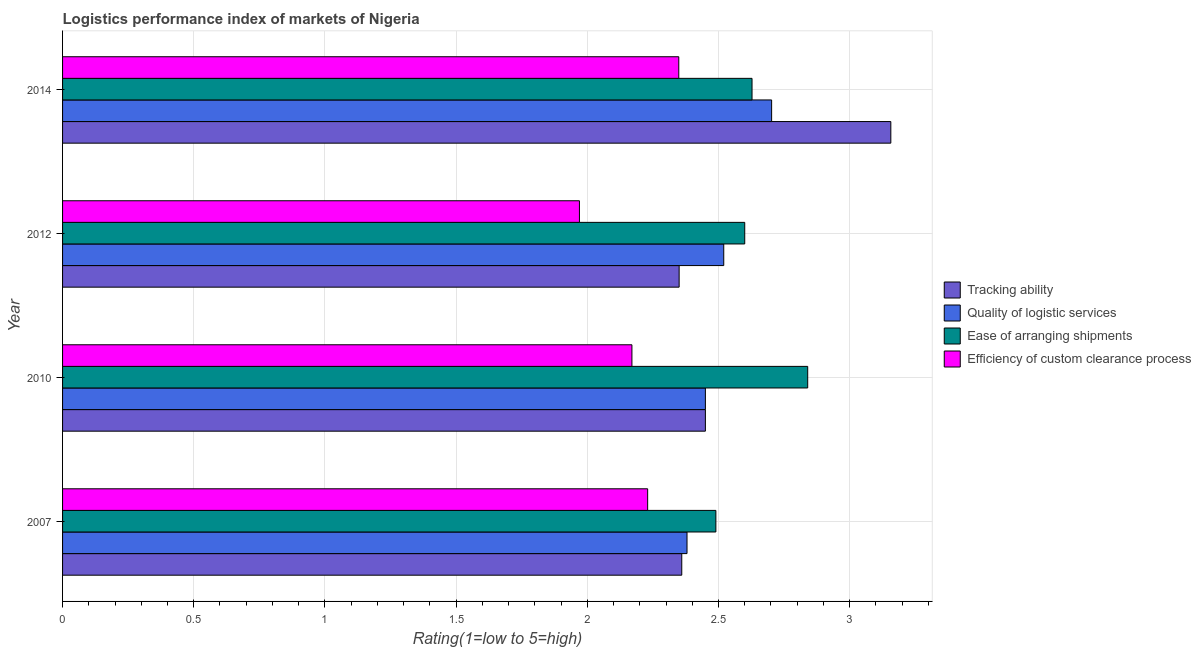How many different coloured bars are there?
Keep it short and to the point. 4. How many groups of bars are there?
Keep it short and to the point. 4. Are the number of bars per tick equal to the number of legend labels?
Your answer should be very brief. Yes. What is the label of the 3rd group of bars from the top?
Your response must be concise. 2010. In how many cases, is the number of bars for a given year not equal to the number of legend labels?
Make the answer very short. 0. What is the lpi rating of tracking ability in 2007?
Ensure brevity in your answer.  2.36. Across all years, what is the maximum lpi rating of efficiency of custom clearance process?
Offer a terse response. 2.35. Across all years, what is the minimum lpi rating of efficiency of custom clearance process?
Provide a short and direct response. 1.97. In which year was the lpi rating of quality of logistic services maximum?
Make the answer very short. 2014. In which year was the lpi rating of ease of arranging shipments minimum?
Your answer should be compact. 2007. What is the total lpi rating of quality of logistic services in the graph?
Make the answer very short. 10.05. What is the difference between the lpi rating of efficiency of custom clearance process in 2007 and that in 2014?
Keep it short and to the point. -0.12. What is the difference between the lpi rating of tracking ability in 2010 and the lpi rating of quality of logistic services in 2007?
Offer a very short reply. 0.07. What is the average lpi rating of ease of arranging shipments per year?
Your answer should be very brief. 2.64. In the year 2007, what is the difference between the lpi rating of efficiency of custom clearance process and lpi rating of ease of arranging shipments?
Offer a very short reply. -0.26. What is the ratio of the lpi rating of tracking ability in 2010 to that in 2014?
Offer a terse response. 0.78. Is the difference between the lpi rating of ease of arranging shipments in 2007 and 2012 greater than the difference between the lpi rating of quality of logistic services in 2007 and 2012?
Offer a very short reply. Yes. What is the difference between the highest and the second highest lpi rating of ease of arranging shipments?
Ensure brevity in your answer.  0.21. What is the difference between the highest and the lowest lpi rating of ease of arranging shipments?
Keep it short and to the point. 0.35. Is it the case that in every year, the sum of the lpi rating of quality of logistic services and lpi rating of efficiency of custom clearance process is greater than the sum of lpi rating of tracking ability and lpi rating of ease of arranging shipments?
Your answer should be compact. No. What does the 3rd bar from the top in 2012 represents?
Your answer should be very brief. Quality of logistic services. What does the 1st bar from the bottom in 2012 represents?
Make the answer very short. Tracking ability. Is it the case that in every year, the sum of the lpi rating of tracking ability and lpi rating of quality of logistic services is greater than the lpi rating of ease of arranging shipments?
Ensure brevity in your answer.  Yes. How many bars are there?
Make the answer very short. 16. How many years are there in the graph?
Your answer should be very brief. 4. Does the graph contain any zero values?
Your answer should be very brief. No. Does the graph contain grids?
Give a very brief answer. Yes. Where does the legend appear in the graph?
Your response must be concise. Center right. How are the legend labels stacked?
Keep it short and to the point. Vertical. What is the title of the graph?
Ensure brevity in your answer.  Logistics performance index of markets of Nigeria. Does "HFC gas" appear as one of the legend labels in the graph?
Give a very brief answer. No. What is the label or title of the X-axis?
Offer a terse response. Rating(1=low to 5=high). What is the label or title of the Y-axis?
Your answer should be very brief. Year. What is the Rating(1=low to 5=high) in Tracking ability in 2007?
Keep it short and to the point. 2.36. What is the Rating(1=low to 5=high) of Quality of logistic services in 2007?
Give a very brief answer. 2.38. What is the Rating(1=low to 5=high) of Ease of arranging shipments in 2007?
Provide a succinct answer. 2.49. What is the Rating(1=low to 5=high) in Efficiency of custom clearance process in 2007?
Provide a short and direct response. 2.23. What is the Rating(1=low to 5=high) in Tracking ability in 2010?
Offer a terse response. 2.45. What is the Rating(1=low to 5=high) in Quality of logistic services in 2010?
Provide a short and direct response. 2.45. What is the Rating(1=low to 5=high) of Ease of arranging shipments in 2010?
Your answer should be very brief. 2.84. What is the Rating(1=low to 5=high) of Efficiency of custom clearance process in 2010?
Give a very brief answer. 2.17. What is the Rating(1=low to 5=high) of Tracking ability in 2012?
Provide a succinct answer. 2.35. What is the Rating(1=low to 5=high) in Quality of logistic services in 2012?
Offer a very short reply. 2.52. What is the Rating(1=low to 5=high) of Efficiency of custom clearance process in 2012?
Make the answer very short. 1.97. What is the Rating(1=low to 5=high) in Tracking ability in 2014?
Offer a very short reply. 3.16. What is the Rating(1=low to 5=high) of Quality of logistic services in 2014?
Your response must be concise. 2.7. What is the Rating(1=low to 5=high) in Ease of arranging shipments in 2014?
Your answer should be compact. 2.63. What is the Rating(1=low to 5=high) of Efficiency of custom clearance process in 2014?
Your answer should be compact. 2.35. Across all years, what is the maximum Rating(1=low to 5=high) in Tracking ability?
Keep it short and to the point. 3.16. Across all years, what is the maximum Rating(1=low to 5=high) in Quality of logistic services?
Your answer should be compact. 2.7. Across all years, what is the maximum Rating(1=low to 5=high) in Ease of arranging shipments?
Your response must be concise. 2.84. Across all years, what is the maximum Rating(1=low to 5=high) of Efficiency of custom clearance process?
Your answer should be compact. 2.35. Across all years, what is the minimum Rating(1=low to 5=high) in Tracking ability?
Provide a short and direct response. 2.35. Across all years, what is the minimum Rating(1=low to 5=high) of Quality of logistic services?
Offer a terse response. 2.38. Across all years, what is the minimum Rating(1=low to 5=high) in Ease of arranging shipments?
Your answer should be compact. 2.49. Across all years, what is the minimum Rating(1=low to 5=high) in Efficiency of custom clearance process?
Your response must be concise. 1.97. What is the total Rating(1=low to 5=high) in Tracking ability in the graph?
Ensure brevity in your answer.  10.32. What is the total Rating(1=low to 5=high) of Quality of logistic services in the graph?
Your answer should be very brief. 10.05. What is the total Rating(1=low to 5=high) of Ease of arranging shipments in the graph?
Make the answer very short. 10.56. What is the total Rating(1=low to 5=high) of Efficiency of custom clearance process in the graph?
Make the answer very short. 8.72. What is the difference between the Rating(1=low to 5=high) of Tracking ability in 2007 and that in 2010?
Ensure brevity in your answer.  -0.09. What is the difference between the Rating(1=low to 5=high) in Quality of logistic services in 2007 and that in 2010?
Provide a succinct answer. -0.07. What is the difference between the Rating(1=low to 5=high) of Ease of arranging shipments in 2007 and that in 2010?
Offer a very short reply. -0.35. What is the difference between the Rating(1=low to 5=high) of Efficiency of custom clearance process in 2007 and that in 2010?
Your answer should be very brief. 0.06. What is the difference between the Rating(1=low to 5=high) in Tracking ability in 2007 and that in 2012?
Your answer should be compact. 0.01. What is the difference between the Rating(1=low to 5=high) of Quality of logistic services in 2007 and that in 2012?
Make the answer very short. -0.14. What is the difference between the Rating(1=low to 5=high) in Ease of arranging shipments in 2007 and that in 2012?
Keep it short and to the point. -0.11. What is the difference between the Rating(1=low to 5=high) of Efficiency of custom clearance process in 2007 and that in 2012?
Ensure brevity in your answer.  0.26. What is the difference between the Rating(1=low to 5=high) in Tracking ability in 2007 and that in 2014?
Offer a terse response. -0.8. What is the difference between the Rating(1=low to 5=high) of Quality of logistic services in 2007 and that in 2014?
Keep it short and to the point. -0.32. What is the difference between the Rating(1=low to 5=high) of Ease of arranging shipments in 2007 and that in 2014?
Your answer should be very brief. -0.14. What is the difference between the Rating(1=low to 5=high) of Efficiency of custom clearance process in 2007 and that in 2014?
Keep it short and to the point. -0.12. What is the difference between the Rating(1=low to 5=high) of Tracking ability in 2010 and that in 2012?
Your answer should be compact. 0.1. What is the difference between the Rating(1=low to 5=high) in Quality of logistic services in 2010 and that in 2012?
Your answer should be compact. -0.07. What is the difference between the Rating(1=low to 5=high) in Ease of arranging shipments in 2010 and that in 2012?
Give a very brief answer. 0.24. What is the difference between the Rating(1=low to 5=high) in Tracking ability in 2010 and that in 2014?
Your answer should be compact. -0.71. What is the difference between the Rating(1=low to 5=high) in Quality of logistic services in 2010 and that in 2014?
Give a very brief answer. -0.25. What is the difference between the Rating(1=low to 5=high) of Ease of arranging shipments in 2010 and that in 2014?
Ensure brevity in your answer.  0.21. What is the difference between the Rating(1=low to 5=high) of Efficiency of custom clearance process in 2010 and that in 2014?
Provide a succinct answer. -0.18. What is the difference between the Rating(1=low to 5=high) of Tracking ability in 2012 and that in 2014?
Your response must be concise. -0.81. What is the difference between the Rating(1=low to 5=high) in Quality of logistic services in 2012 and that in 2014?
Your answer should be very brief. -0.18. What is the difference between the Rating(1=low to 5=high) in Ease of arranging shipments in 2012 and that in 2014?
Ensure brevity in your answer.  -0.03. What is the difference between the Rating(1=low to 5=high) of Efficiency of custom clearance process in 2012 and that in 2014?
Provide a succinct answer. -0.38. What is the difference between the Rating(1=low to 5=high) in Tracking ability in 2007 and the Rating(1=low to 5=high) in Quality of logistic services in 2010?
Give a very brief answer. -0.09. What is the difference between the Rating(1=low to 5=high) of Tracking ability in 2007 and the Rating(1=low to 5=high) of Ease of arranging shipments in 2010?
Your response must be concise. -0.48. What is the difference between the Rating(1=low to 5=high) of Tracking ability in 2007 and the Rating(1=low to 5=high) of Efficiency of custom clearance process in 2010?
Your response must be concise. 0.19. What is the difference between the Rating(1=low to 5=high) in Quality of logistic services in 2007 and the Rating(1=low to 5=high) in Ease of arranging shipments in 2010?
Keep it short and to the point. -0.46. What is the difference between the Rating(1=low to 5=high) of Quality of logistic services in 2007 and the Rating(1=low to 5=high) of Efficiency of custom clearance process in 2010?
Make the answer very short. 0.21. What is the difference between the Rating(1=low to 5=high) in Ease of arranging shipments in 2007 and the Rating(1=low to 5=high) in Efficiency of custom clearance process in 2010?
Your answer should be compact. 0.32. What is the difference between the Rating(1=low to 5=high) in Tracking ability in 2007 and the Rating(1=low to 5=high) in Quality of logistic services in 2012?
Offer a very short reply. -0.16. What is the difference between the Rating(1=low to 5=high) of Tracking ability in 2007 and the Rating(1=low to 5=high) of Ease of arranging shipments in 2012?
Make the answer very short. -0.24. What is the difference between the Rating(1=low to 5=high) in Tracking ability in 2007 and the Rating(1=low to 5=high) in Efficiency of custom clearance process in 2012?
Your answer should be compact. 0.39. What is the difference between the Rating(1=low to 5=high) in Quality of logistic services in 2007 and the Rating(1=low to 5=high) in Ease of arranging shipments in 2012?
Your response must be concise. -0.22. What is the difference between the Rating(1=low to 5=high) in Quality of logistic services in 2007 and the Rating(1=low to 5=high) in Efficiency of custom clearance process in 2012?
Offer a terse response. 0.41. What is the difference between the Rating(1=low to 5=high) in Ease of arranging shipments in 2007 and the Rating(1=low to 5=high) in Efficiency of custom clearance process in 2012?
Give a very brief answer. 0.52. What is the difference between the Rating(1=low to 5=high) in Tracking ability in 2007 and the Rating(1=low to 5=high) in Quality of logistic services in 2014?
Provide a short and direct response. -0.34. What is the difference between the Rating(1=low to 5=high) of Tracking ability in 2007 and the Rating(1=low to 5=high) of Ease of arranging shipments in 2014?
Keep it short and to the point. -0.27. What is the difference between the Rating(1=low to 5=high) in Tracking ability in 2007 and the Rating(1=low to 5=high) in Efficiency of custom clearance process in 2014?
Your answer should be very brief. 0.01. What is the difference between the Rating(1=low to 5=high) of Quality of logistic services in 2007 and the Rating(1=low to 5=high) of Ease of arranging shipments in 2014?
Give a very brief answer. -0.25. What is the difference between the Rating(1=low to 5=high) of Quality of logistic services in 2007 and the Rating(1=low to 5=high) of Efficiency of custom clearance process in 2014?
Keep it short and to the point. 0.03. What is the difference between the Rating(1=low to 5=high) in Ease of arranging shipments in 2007 and the Rating(1=low to 5=high) in Efficiency of custom clearance process in 2014?
Give a very brief answer. 0.14. What is the difference between the Rating(1=low to 5=high) of Tracking ability in 2010 and the Rating(1=low to 5=high) of Quality of logistic services in 2012?
Make the answer very short. -0.07. What is the difference between the Rating(1=low to 5=high) in Tracking ability in 2010 and the Rating(1=low to 5=high) in Ease of arranging shipments in 2012?
Give a very brief answer. -0.15. What is the difference between the Rating(1=low to 5=high) in Tracking ability in 2010 and the Rating(1=low to 5=high) in Efficiency of custom clearance process in 2012?
Ensure brevity in your answer.  0.48. What is the difference between the Rating(1=low to 5=high) of Quality of logistic services in 2010 and the Rating(1=low to 5=high) of Ease of arranging shipments in 2012?
Give a very brief answer. -0.15. What is the difference between the Rating(1=low to 5=high) in Quality of logistic services in 2010 and the Rating(1=low to 5=high) in Efficiency of custom clearance process in 2012?
Offer a very short reply. 0.48. What is the difference between the Rating(1=low to 5=high) in Ease of arranging shipments in 2010 and the Rating(1=low to 5=high) in Efficiency of custom clearance process in 2012?
Your response must be concise. 0.87. What is the difference between the Rating(1=low to 5=high) in Tracking ability in 2010 and the Rating(1=low to 5=high) in Quality of logistic services in 2014?
Ensure brevity in your answer.  -0.25. What is the difference between the Rating(1=low to 5=high) in Tracking ability in 2010 and the Rating(1=low to 5=high) in Ease of arranging shipments in 2014?
Make the answer very short. -0.18. What is the difference between the Rating(1=low to 5=high) of Tracking ability in 2010 and the Rating(1=low to 5=high) of Efficiency of custom clearance process in 2014?
Your response must be concise. 0.1. What is the difference between the Rating(1=low to 5=high) of Quality of logistic services in 2010 and the Rating(1=low to 5=high) of Ease of arranging shipments in 2014?
Offer a terse response. -0.18. What is the difference between the Rating(1=low to 5=high) in Quality of logistic services in 2010 and the Rating(1=low to 5=high) in Efficiency of custom clearance process in 2014?
Your response must be concise. 0.1. What is the difference between the Rating(1=low to 5=high) of Ease of arranging shipments in 2010 and the Rating(1=low to 5=high) of Efficiency of custom clearance process in 2014?
Keep it short and to the point. 0.49. What is the difference between the Rating(1=low to 5=high) in Tracking ability in 2012 and the Rating(1=low to 5=high) in Quality of logistic services in 2014?
Make the answer very short. -0.35. What is the difference between the Rating(1=low to 5=high) in Tracking ability in 2012 and the Rating(1=low to 5=high) in Ease of arranging shipments in 2014?
Offer a very short reply. -0.28. What is the difference between the Rating(1=low to 5=high) of Tracking ability in 2012 and the Rating(1=low to 5=high) of Efficiency of custom clearance process in 2014?
Offer a very short reply. 0. What is the difference between the Rating(1=low to 5=high) of Quality of logistic services in 2012 and the Rating(1=low to 5=high) of Ease of arranging shipments in 2014?
Give a very brief answer. -0.11. What is the difference between the Rating(1=low to 5=high) in Quality of logistic services in 2012 and the Rating(1=low to 5=high) in Efficiency of custom clearance process in 2014?
Ensure brevity in your answer.  0.17. What is the difference between the Rating(1=low to 5=high) of Ease of arranging shipments in 2012 and the Rating(1=low to 5=high) of Efficiency of custom clearance process in 2014?
Ensure brevity in your answer.  0.25. What is the average Rating(1=low to 5=high) of Tracking ability per year?
Make the answer very short. 2.58. What is the average Rating(1=low to 5=high) in Quality of logistic services per year?
Give a very brief answer. 2.51. What is the average Rating(1=low to 5=high) of Ease of arranging shipments per year?
Keep it short and to the point. 2.64. What is the average Rating(1=low to 5=high) of Efficiency of custom clearance process per year?
Your answer should be very brief. 2.18. In the year 2007, what is the difference between the Rating(1=low to 5=high) in Tracking ability and Rating(1=low to 5=high) in Quality of logistic services?
Offer a very short reply. -0.02. In the year 2007, what is the difference between the Rating(1=low to 5=high) of Tracking ability and Rating(1=low to 5=high) of Ease of arranging shipments?
Give a very brief answer. -0.13. In the year 2007, what is the difference between the Rating(1=low to 5=high) of Tracking ability and Rating(1=low to 5=high) of Efficiency of custom clearance process?
Your answer should be very brief. 0.13. In the year 2007, what is the difference between the Rating(1=low to 5=high) in Quality of logistic services and Rating(1=low to 5=high) in Ease of arranging shipments?
Provide a short and direct response. -0.11. In the year 2007, what is the difference between the Rating(1=low to 5=high) of Ease of arranging shipments and Rating(1=low to 5=high) of Efficiency of custom clearance process?
Keep it short and to the point. 0.26. In the year 2010, what is the difference between the Rating(1=low to 5=high) of Tracking ability and Rating(1=low to 5=high) of Quality of logistic services?
Ensure brevity in your answer.  0. In the year 2010, what is the difference between the Rating(1=low to 5=high) in Tracking ability and Rating(1=low to 5=high) in Ease of arranging shipments?
Make the answer very short. -0.39. In the year 2010, what is the difference between the Rating(1=low to 5=high) in Tracking ability and Rating(1=low to 5=high) in Efficiency of custom clearance process?
Your answer should be very brief. 0.28. In the year 2010, what is the difference between the Rating(1=low to 5=high) of Quality of logistic services and Rating(1=low to 5=high) of Ease of arranging shipments?
Provide a short and direct response. -0.39. In the year 2010, what is the difference between the Rating(1=low to 5=high) in Quality of logistic services and Rating(1=low to 5=high) in Efficiency of custom clearance process?
Give a very brief answer. 0.28. In the year 2010, what is the difference between the Rating(1=low to 5=high) of Ease of arranging shipments and Rating(1=low to 5=high) of Efficiency of custom clearance process?
Your answer should be very brief. 0.67. In the year 2012, what is the difference between the Rating(1=low to 5=high) in Tracking ability and Rating(1=low to 5=high) in Quality of logistic services?
Offer a terse response. -0.17. In the year 2012, what is the difference between the Rating(1=low to 5=high) of Tracking ability and Rating(1=low to 5=high) of Ease of arranging shipments?
Keep it short and to the point. -0.25. In the year 2012, what is the difference between the Rating(1=low to 5=high) of Tracking ability and Rating(1=low to 5=high) of Efficiency of custom clearance process?
Provide a short and direct response. 0.38. In the year 2012, what is the difference between the Rating(1=low to 5=high) of Quality of logistic services and Rating(1=low to 5=high) of Ease of arranging shipments?
Offer a terse response. -0.08. In the year 2012, what is the difference between the Rating(1=low to 5=high) in Quality of logistic services and Rating(1=low to 5=high) in Efficiency of custom clearance process?
Provide a short and direct response. 0.55. In the year 2012, what is the difference between the Rating(1=low to 5=high) of Ease of arranging shipments and Rating(1=low to 5=high) of Efficiency of custom clearance process?
Your answer should be very brief. 0.63. In the year 2014, what is the difference between the Rating(1=low to 5=high) of Tracking ability and Rating(1=low to 5=high) of Quality of logistic services?
Make the answer very short. 0.45. In the year 2014, what is the difference between the Rating(1=low to 5=high) of Tracking ability and Rating(1=low to 5=high) of Ease of arranging shipments?
Your response must be concise. 0.53. In the year 2014, what is the difference between the Rating(1=low to 5=high) in Tracking ability and Rating(1=low to 5=high) in Efficiency of custom clearance process?
Your response must be concise. 0.81. In the year 2014, what is the difference between the Rating(1=low to 5=high) of Quality of logistic services and Rating(1=low to 5=high) of Ease of arranging shipments?
Give a very brief answer. 0.07. In the year 2014, what is the difference between the Rating(1=low to 5=high) in Quality of logistic services and Rating(1=low to 5=high) in Efficiency of custom clearance process?
Give a very brief answer. 0.35. In the year 2014, what is the difference between the Rating(1=low to 5=high) of Ease of arranging shipments and Rating(1=low to 5=high) of Efficiency of custom clearance process?
Your response must be concise. 0.28. What is the ratio of the Rating(1=low to 5=high) of Tracking ability in 2007 to that in 2010?
Offer a terse response. 0.96. What is the ratio of the Rating(1=low to 5=high) of Quality of logistic services in 2007 to that in 2010?
Your response must be concise. 0.97. What is the ratio of the Rating(1=low to 5=high) of Ease of arranging shipments in 2007 to that in 2010?
Ensure brevity in your answer.  0.88. What is the ratio of the Rating(1=low to 5=high) in Efficiency of custom clearance process in 2007 to that in 2010?
Make the answer very short. 1.03. What is the ratio of the Rating(1=low to 5=high) of Tracking ability in 2007 to that in 2012?
Give a very brief answer. 1. What is the ratio of the Rating(1=low to 5=high) of Ease of arranging shipments in 2007 to that in 2012?
Your response must be concise. 0.96. What is the ratio of the Rating(1=low to 5=high) of Efficiency of custom clearance process in 2007 to that in 2012?
Offer a very short reply. 1.13. What is the ratio of the Rating(1=low to 5=high) of Tracking ability in 2007 to that in 2014?
Make the answer very short. 0.75. What is the ratio of the Rating(1=low to 5=high) in Quality of logistic services in 2007 to that in 2014?
Your answer should be very brief. 0.88. What is the ratio of the Rating(1=low to 5=high) in Ease of arranging shipments in 2007 to that in 2014?
Give a very brief answer. 0.95. What is the ratio of the Rating(1=low to 5=high) in Efficiency of custom clearance process in 2007 to that in 2014?
Offer a terse response. 0.95. What is the ratio of the Rating(1=low to 5=high) in Tracking ability in 2010 to that in 2012?
Offer a terse response. 1.04. What is the ratio of the Rating(1=low to 5=high) in Quality of logistic services in 2010 to that in 2012?
Your answer should be compact. 0.97. What is the ratio of the Rating(1=low to 5=high) in Ease of arranging shipments in 2010 to that in 2012?
Your response must be concise. 1.09. What is the ratio of the Rating(1=low to 5=high) in Efficiency of custom clearance process in 2010 to that in 2012?
Provide a succinct answer. 1.1. What is the ratio of the Rating(1=low to 5=high) of Tracking ability in 2010 to that in 2014?
Your answer should be compact. 0.78. What is the ratio of the Rating(1=low to 5=high) in Quality of logistic services in 2010 to that in 2014?
Keep it short and to the point. 0.91. What is the ratio of the Rating(1=low to 5=high) in Ease of arranging shipments in 2010 to that in 2014?
Your answer should be compact. 1.08. What is the ratio of the Rating(1=low to 5=high) of Efficiency of custom clearance process in 2010 to that in 2014?
Give a very brief answer. 0.92. What is the ratio of the Rating(1=low to 5=high) in Tracking ability in 2012 to that in 2014?
Your answer should be very brief. 0.74. What is the ratio of the Rating(1=low to 5=high) in Quality of logistic services in 2012 to that in 2014?
Keep it short and to the point. 0.93. What is the ratio of the Rating(1=low to 5=high) of Ease of arranging shipments in 2012 to that in 2014?
Offer a terse response. 0.99. What is the ratio of the Rating(1=low to 5=high) of Efficiency of custom clearance process in 2012 to that in 2014?
Provide a succinct answer. 0.84. What is the difference between the highest and the second highest Rating(1=low to 5=high) in Tracking ability?
Give a very brief answer. 0.71. What is the difference between the highest and the second highest Rating(1=low to 5=high) in Quality of logistic services?
Provide a succinct answer. 0.18. What is the difference between the highest and the second highest Rating(1=low to 5=high) in Ease of arranging shipments?
Offer a very short reply. 0.21. What is the difference between the highest and the second highest Rating(1=low to 5=high) of Efficiency of custom clearance process?
Offer a very short reply. 0.12. What is the difference between the highest and the lowest Rating(1=low to 5=high) of Tracking ability?
Your answer should be very brief. 0.81. What is the difference between the highest and the lowest Rating(1=low to 5=high) of Quality of logistic services?
Your answer should be very brief. 0.32. What is the difference between the highest and the lowest Rating(1=low to 5=high) in Ease of arranging shipments?
Your response must be concise. 0.35. What is the difference between the highest and the lowest Rating(1=low to 5=high) of Efficiency of custom clearance process?
Make the answer very short. 0.38. 